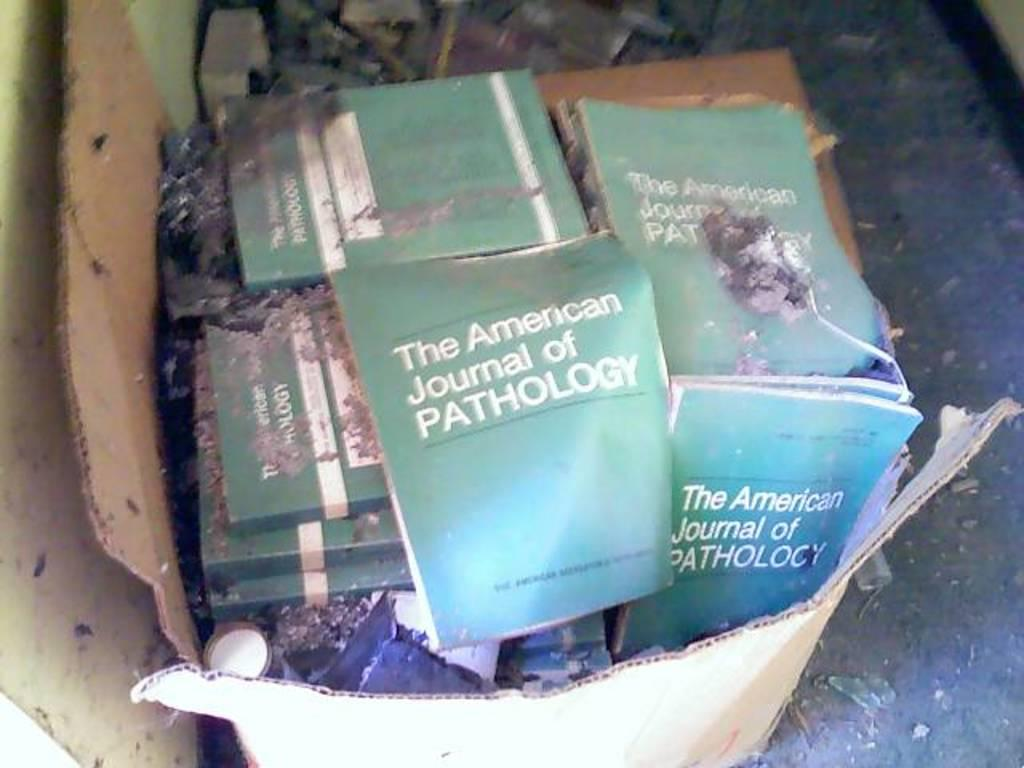<image>
Share a concise interpretation of the image provided. Many copies of The American Journal of Pathology sit in a box among some rubble. 